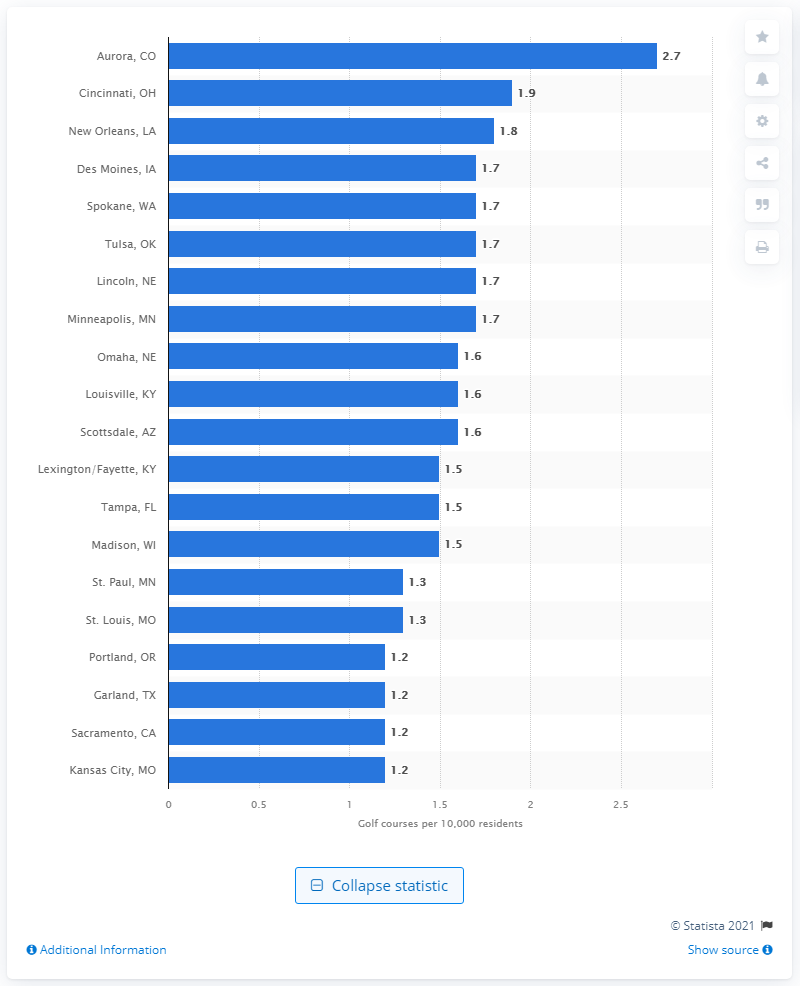Specify some key components in this picture. Aurora, Colorado had the highest density of golf courses in 2020. 